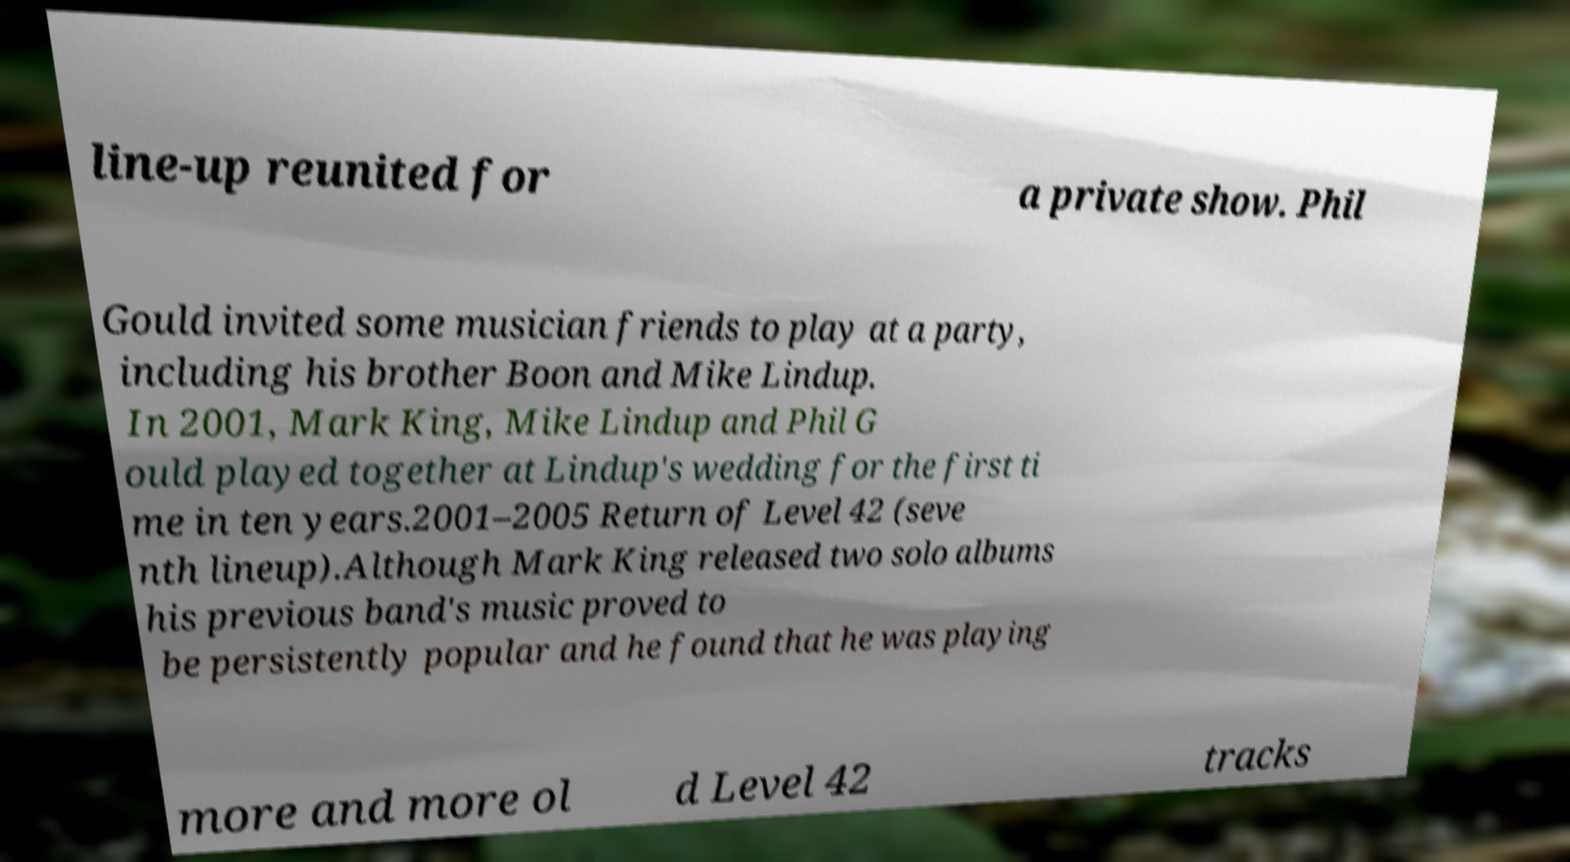What messages or text are displayed in this image? I need them in a readable, typed format. line-up reunited for a private show. Phil Gould invited some musician friends to play at a party, including his brother Boon and Mike Lindup. In 2001, Mark King, Mike Lindup and Phil G ould played together at Lindup's wedding for the first ti me in ten years.2001–2005 Return of Level 42 (seve nth lineup).Although Mark King released two solo albums his previous band's music proved to be persistently popular and he found that he was playing more and more ol d Level 42 tracks 